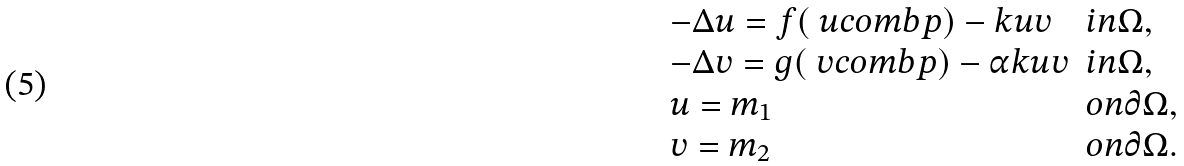Convert formula to latex. <formula><loc_0><loc_0><loc_500><loc_500>\begin{array} { l l } - \Delta u = f ( \ u c o m b p ) - k u v & i n \Omega , \\ - \Delta v = g ( \ v c o m b p ) - \alpha k u v & i n \Omega , \\ u = m _ { 1 } & o n \partial \Omega , \\ v = m _ { 2 } & o n \partial \Omega . \end{array}</formula> 